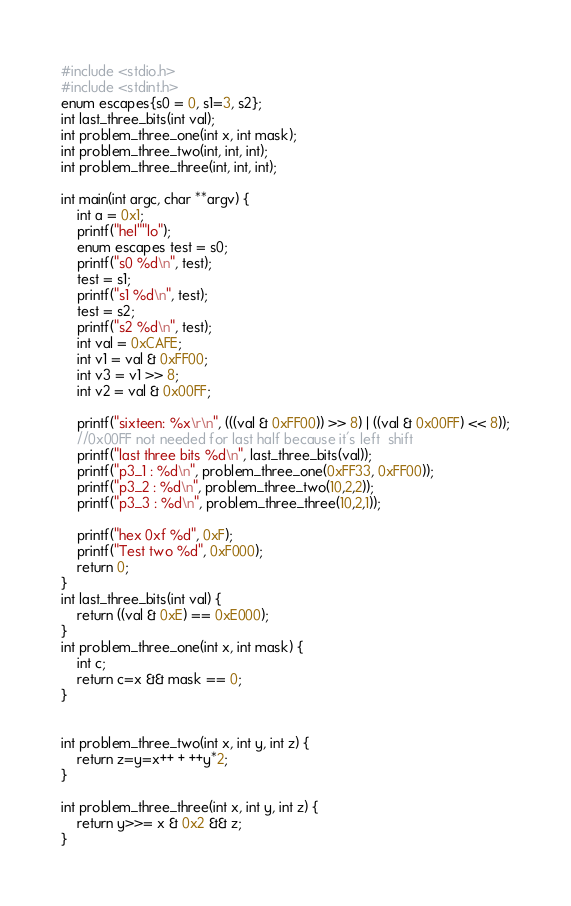Convert code to text. <code><loc_0><loc_0><loc_500><loc_500><_C_>#include <stdio.h>
#include <stdint.h>
enum escapes{s0 = 0, s1=3, s2};
int last_three_bits(int val);
int problem_three_one(int x, int mask);
int problem_three_two(int, int, int);
int problem_three_three(int, int, int);

int main(int argc, char **argv) {
    int a = 0x1;
    printf("hel""lo");
    enum escapes test = s0;
    printf("s0 %d\n", test);
    test = s1;
    printf("s1 %d\n", test);
    test = s2;
    printf("s2 %d\n", test);
    int val = 0xCAFE;
    int v1 = val & 0xFF00;
    int v3 = v1 >> 8;
    int v2 = val & 0x00FF;

    printf("sixteen: %x\r\n", (((val & 0xFF00)) >> 8) | ((val & 0x00FF) << 8));
    //0x00FF not needed for last half because it's left  shift
    printf("last three bits %d\n", last_three_bits(val));
    printf("p3_1 : %d\n", problem_three_one(0xFF33, 0xFF00));
    printf("p3_2 : %d\n", problem_three_two(10,2,2));
    printf("p3_3 : %d\n", problem_three_three(10,2,1));

    printf("hex 0xf %d", 0xF);
    printf("Test two %d", 0xF000);
    return 0;
}
int last_three_bits(int val) {
    return ((val & 0xE) == 0xE000);
}
int problem_three_one(int x, int mask) {
    int c;
    return c=x && mask == 0;
}


int problem_three_two(int x, int y, int z) {
    return z=y=x++ + ++y*2;
}

int problem_three_three(int x, int y, int z) {
    return y>>= x & 0x2 && z;
}


</code> 